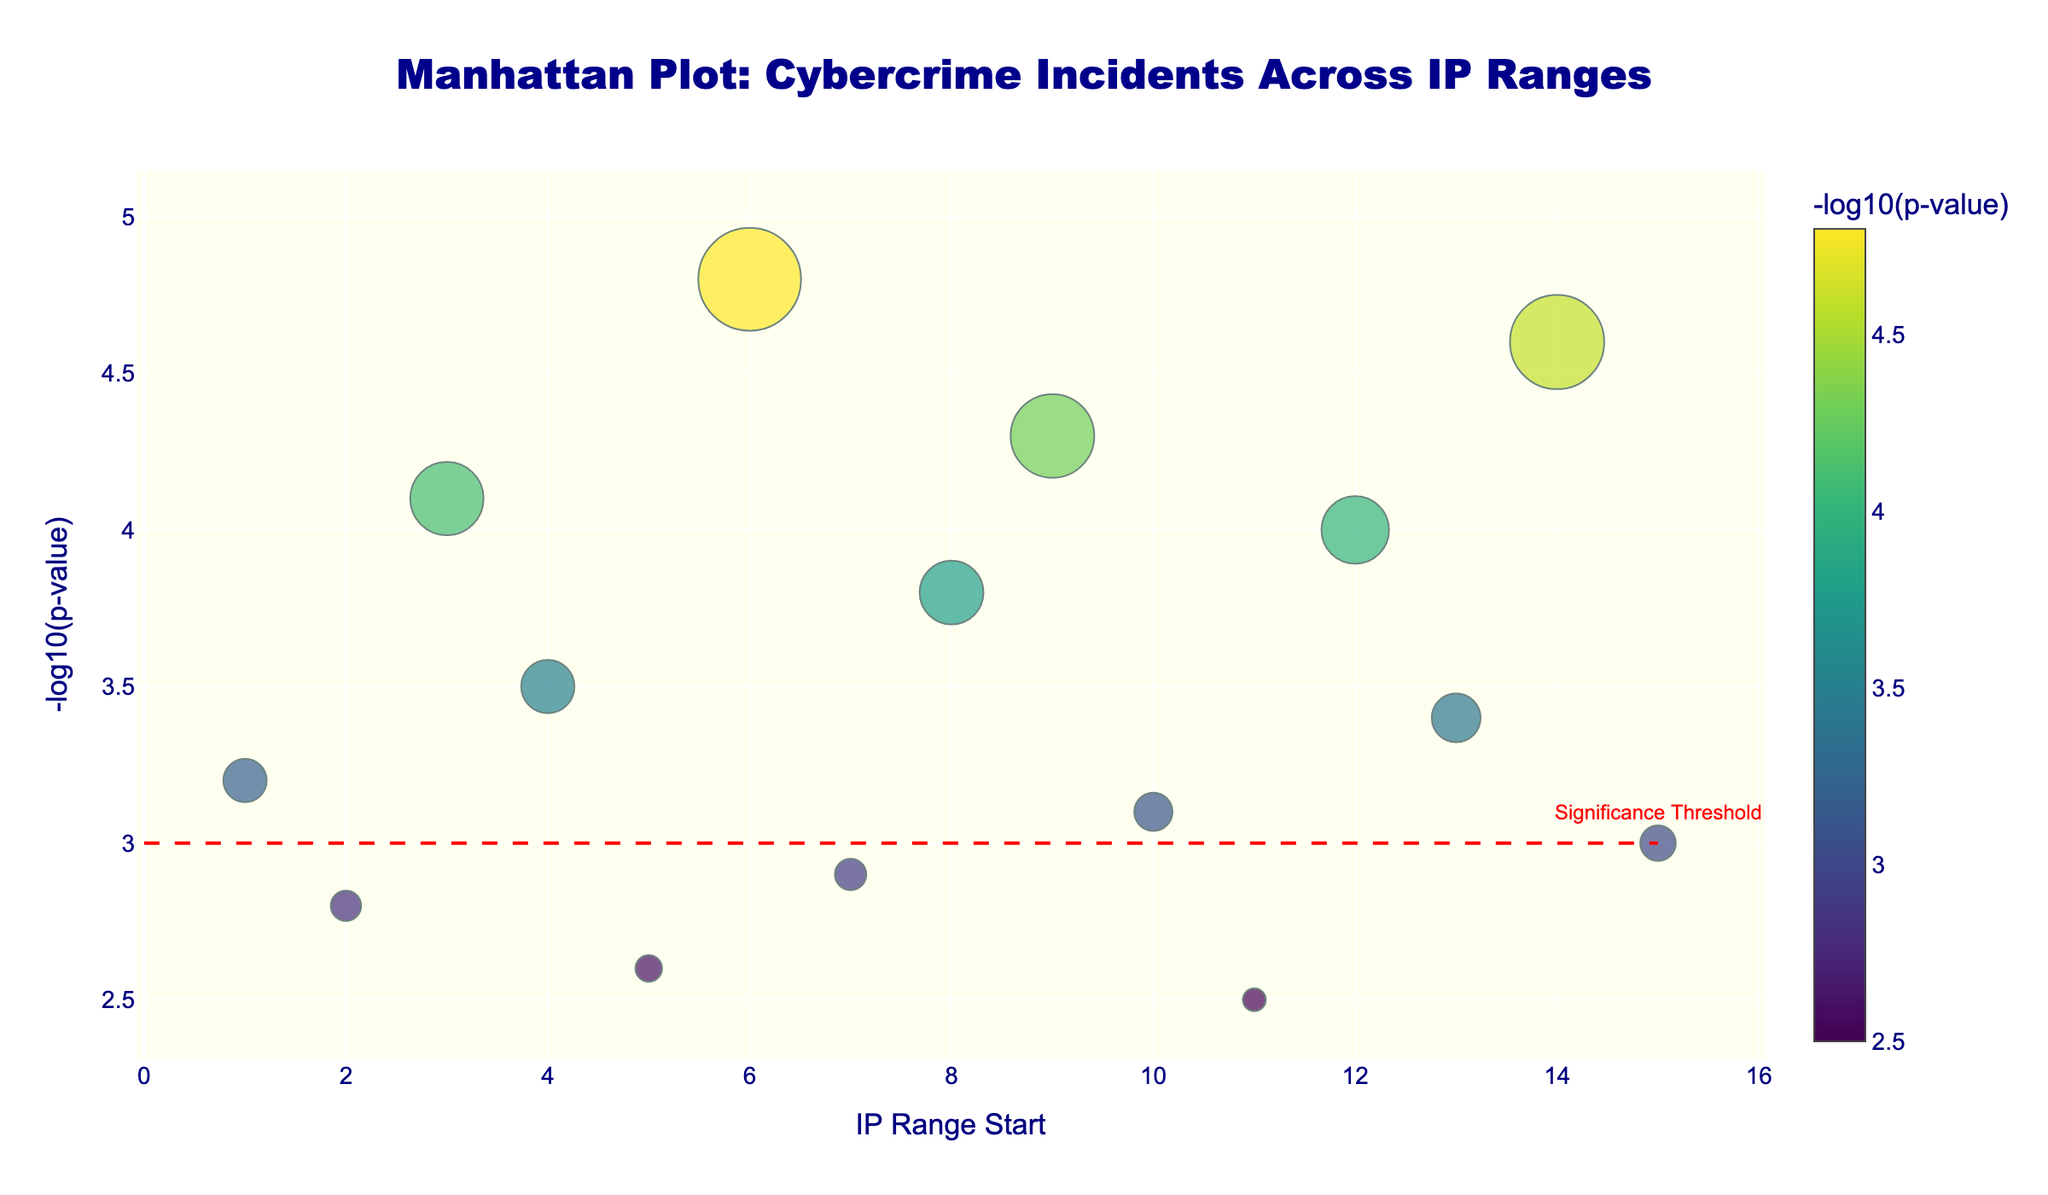What is the title of the plot? The title of the plot is usually positioned at the top and clearly stated in the figure. Here, it reads "Manhattan Plot: Cybercrime Incidents Across IP Ranges"
Answer: Manhattan Plot: Cybercrime Incidents Across IP Ranges How many data points are present in the plot? Each IP range corresponds to a single data point in the plot. Based on the provided data, there are 15 IP ranges, thus 15 data points in total
Answer: 15 What is the most significant IP range in terms of -log10(p-value)? Look for the highest point on the y-axis, which signifies the highest -log10(p-value). In this plot, the highest point corresponds to the 6.0.0.0-6.255.255.255 IP range with a -log10(p-value) of 4.8
Answer: 6.0.0.0-6.255.255.255 Which IP range has the largest number of incidents? The size of the markers is proportional to the number of incidents. The largest marker corresponds to the 6.0.0.0-6.255.255.255 IP range, which has 301 incidents
Answer: 6.0.0.0-6.255.255.255 Which IP ranges have a -log10(p-value) greater than 4? Check the points above the y-axis value of 4. These points correspond to the following IP ranges: 3.0.0.0-3.255.255.255, 6.0.0.0-6.255.255.255, 9.0.0.0-9.255.255.255, 12.0.0.0-12.255.255.255, 14.0.0.0-14.255.255.255
Answer: 3.0.0.0-3.255.255.255, 6.0.0.0-6.255.255.255, 9.0.0.0-9.255.255.255, 12.0.0.0-12.255.255.255, 14.0.0.0-14.255.255.255 What is the significance threshold indicated by the reference line? The reference line is added to indicate a threshold for significance. This line is drawn at y=3, which means the threshold is -log10(p-value) = 3
Answer: 3 How many IP ranges are above the significance threshold? Count the points that are above the reference line at y=3. There are 10 IP ranges above this threshold
Answer: 10 Compare the incidents and -log10(p-value) for IP ranges 8.0.0.0-8.255.255.255 and 9.0.0.0-9.255.255.255. Which one has higher values? Compare both the number of incidents and -log10(p-value). For 8.0.0.0-8.255.255.255: Incidents = 187, -log10(p-value) = 3.8. For 9.0.0.0-9.255.255.255: Incidents = 245, -log10(p-value) = 4.3. Therefore, 9.0.0.0-9.255.255.255 has higher values for both metrics
Answer: 9.0.0.0-9.255.255.255 